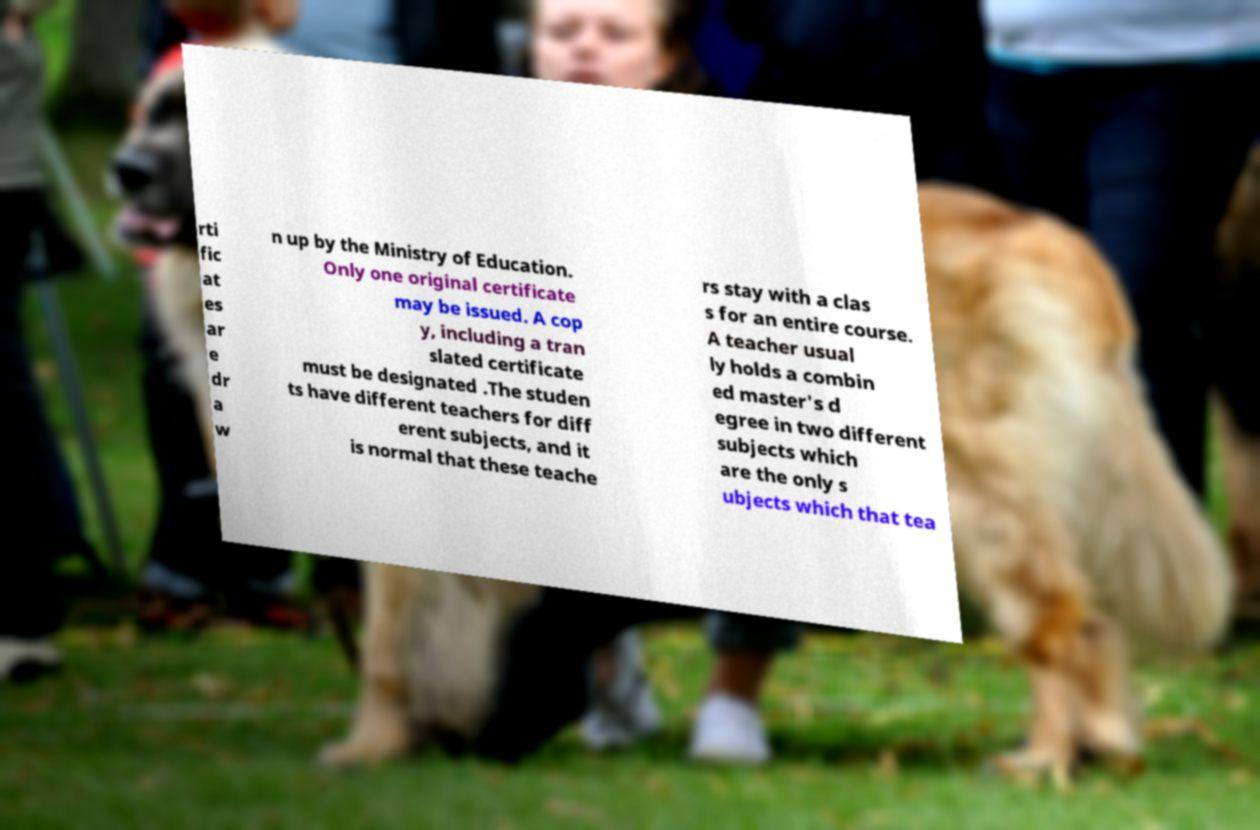Please read and relay the text visible in this image. What does it say? rti fic at es ar e dr a w n up by the Ministry of Education. Only one original certificate may be issued. A cop y, including a tran slated certificate must be designated .The studen ts have different teachers for diff erent subjects, and it is normal that these teache rs stay with a clas s for an entire course. A teacher usual ly holds a combin ed master's d egree in two different subjects which are the only s ubjects which that tea 